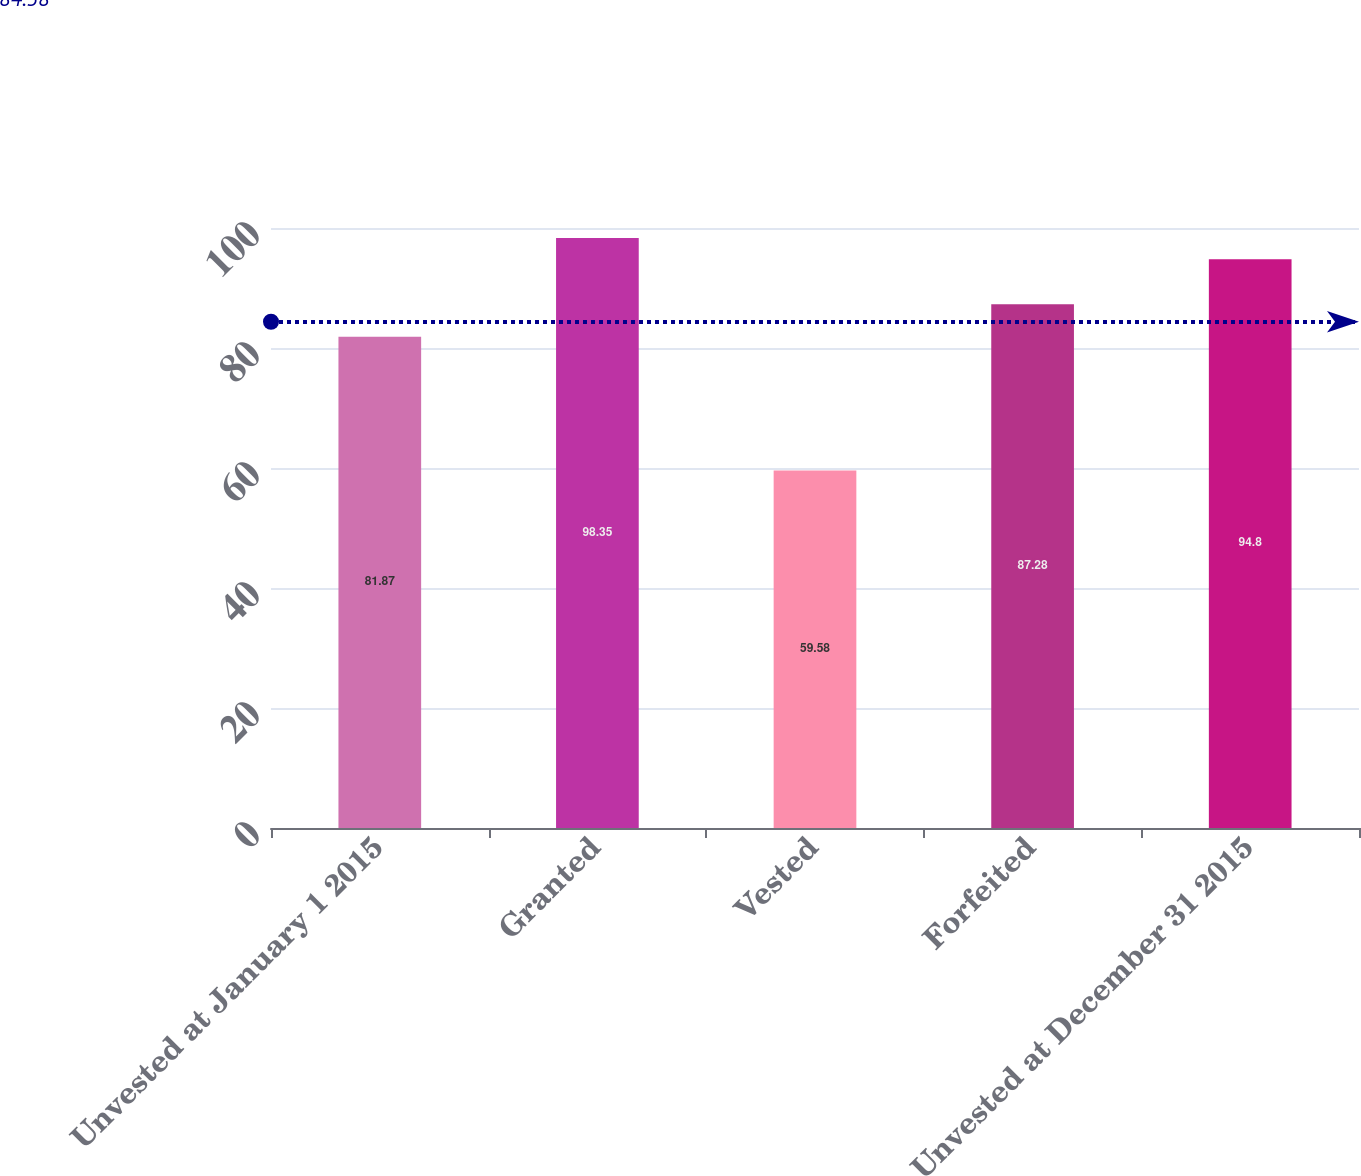Convert chart. <chart><loc_0><loc_0><loc_500><loc_500><bar_chart><fcel>Unvested at January 1 2015<fcel>Granted<fcel>Vested<fcel>Forfeited<fcel>Unvested at December 31 2015<nl><fcel>81.87<fcel>98.35<fcel>59.58<fcel>87.28<fcel>94.8<nl></chart> 